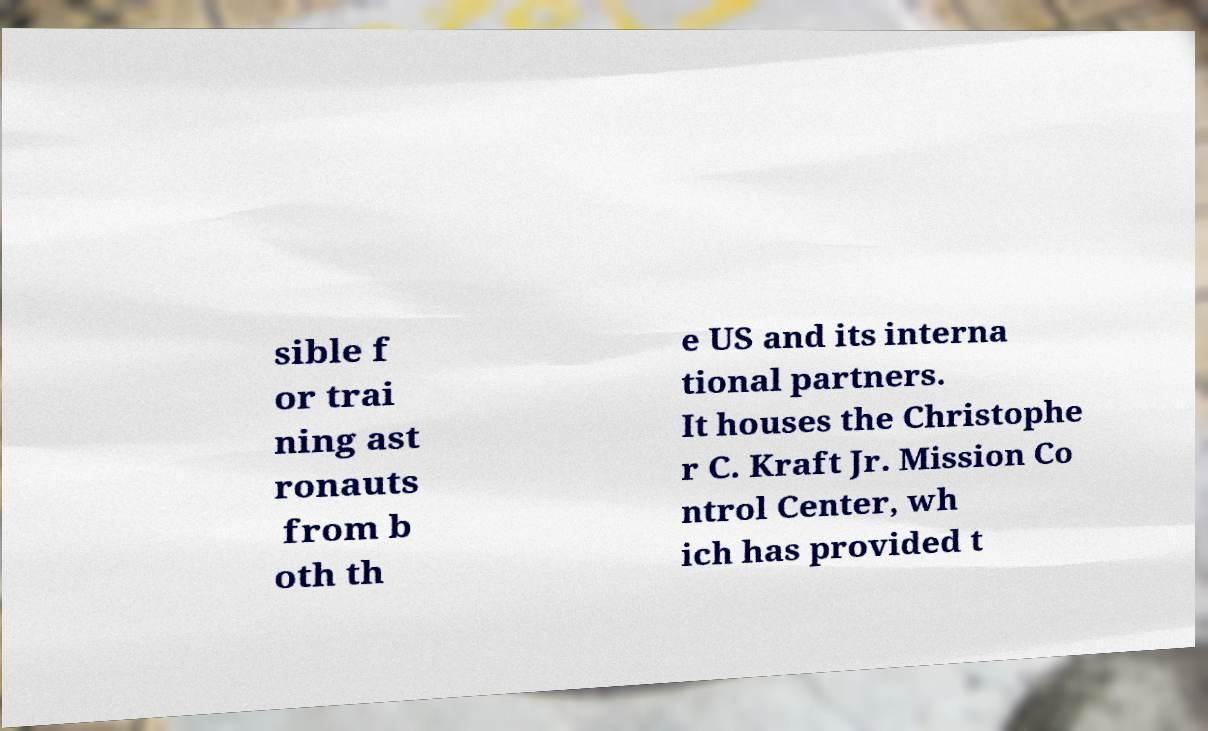What messages or text are displayed in this image? I need them in a readable, typed format. sible f or trai ning ast ronauts from b oth th e US and its interna tional partners. It houses the Christophe r C. Kraft Jr. Mission Co ntrol Center, wh ich has provided t 